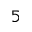<formula> <loc_0><loc_0><loc_500><loc_500>^ { 5 }</formula> 